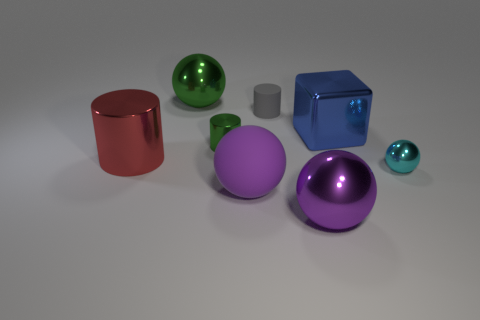Subtract all matte cylinders. How many cylinders are left? 2 Subtract all green spheres. How many spheres are left? 3 Subtract all cyan cubes. How many purple balls are left? 2 Subtract 2 balls. How many balls are left? 2 Add 1 gray matte objects. How many objects exist? 9 Subtract all cubes. How many objects are left? 7 Subtract all yellow cylinders. Subtract all cyan blocks. How many cylinders are left? 3 Subtract all small gray rubber cylinders. Subtract all green metal spheres. How many objects are left? 6 Add 2 big metallic things. How many big metallic things are left? 6 Add 7 big cylinders. How many big cylinders exist? 8 